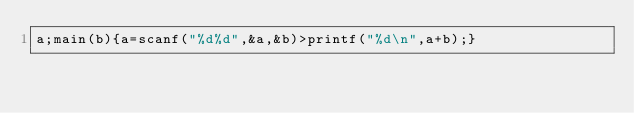<code> <loc_0><loc_0><loc_500><loc_500><_C_>a;main(b){a=scanf("%d%d",&a,&b)>printf("%d\n",a+b);}</code> 